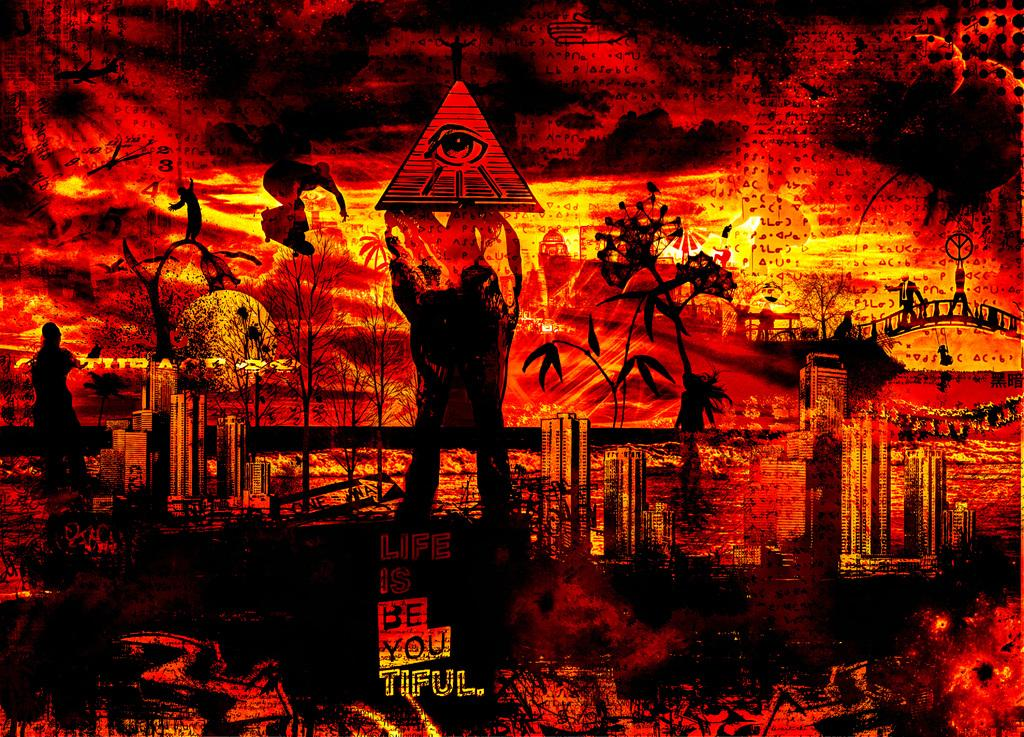<image>
Provide a brief description of the given image. An artwork with a pyramid on it says love is be you tiful. 